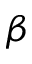Convert formula to latex. <formula><loc_0><loc_0><loc_500><loc_500>\beta</formula> 